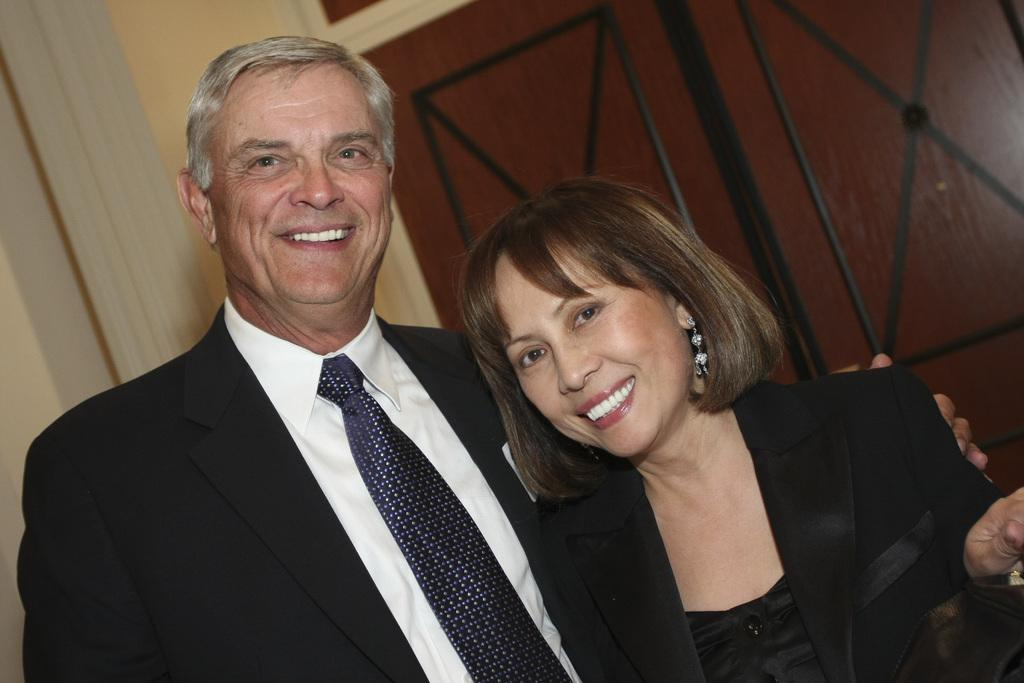How many people are in the image? There are two people in the image, a woman and a man. What are the woman and man doing in the image? The woman and man are standing side by side, watching and smiling. How are the woman and man interacting in the image? The man is holding the woman. What can be seen in the background of the image? There is a wall and a door in the background of the image. What type of butter is being used to adjust the door in the image? There is no butter or door adjustment present in the image. Can you tell me how many times the woman turns her head in the image? There is no indication of the woman turning her head in the image. 